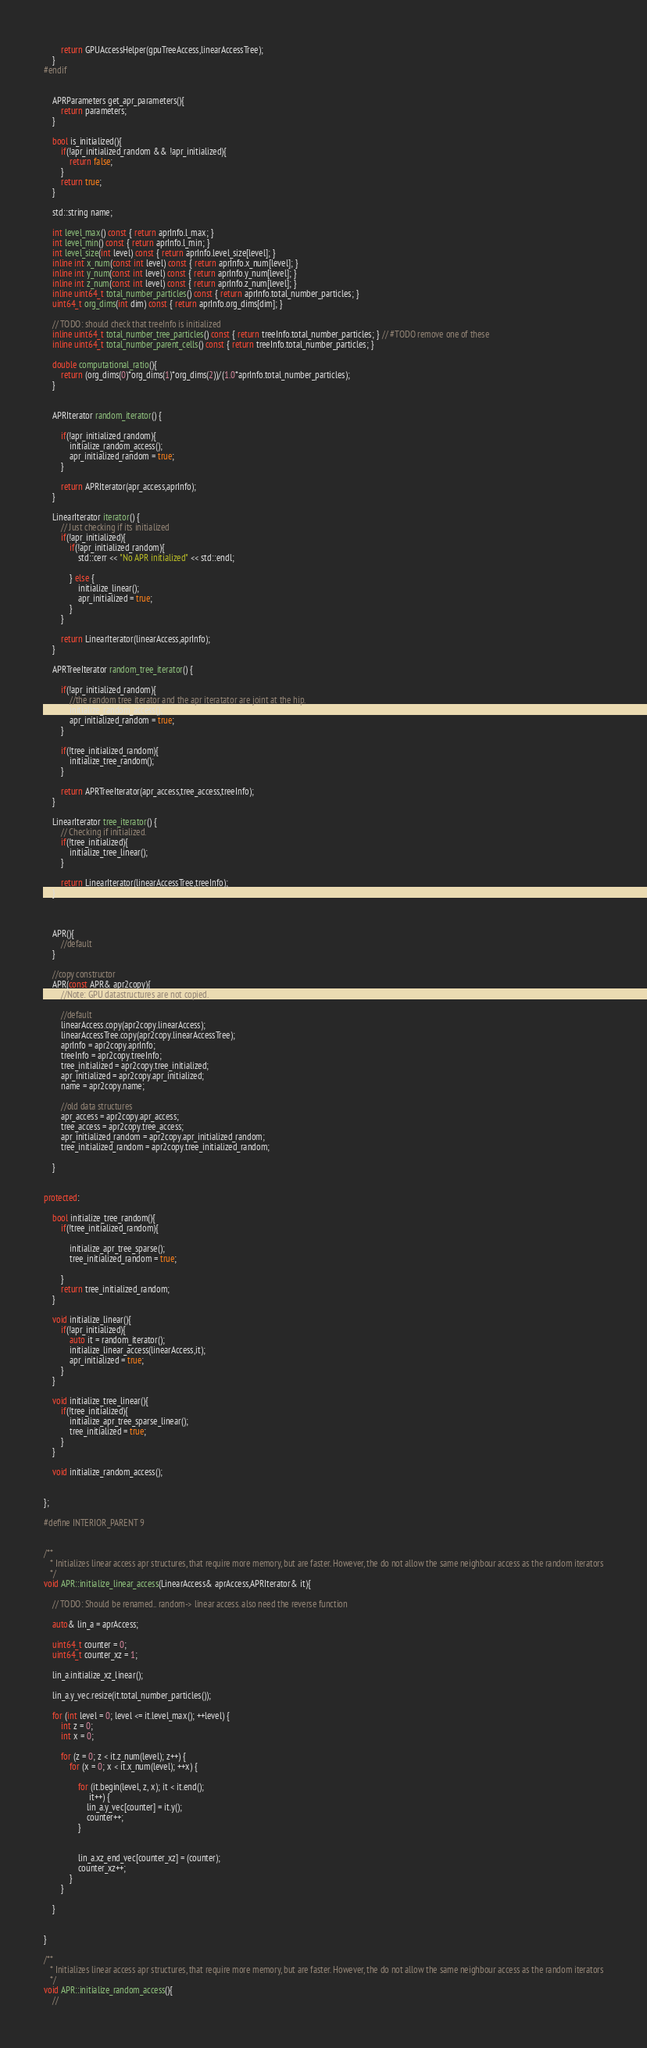Convert code to text. <code><loc_0><loc_0><loc_500><loc_500><_C++_>        return GPUAccessHelper(gpuTreeAccess,linearAccessTree);
    }
#endif


    APRParameters get_apr_parameters(){
        return parameters;
    }

    bool is_initialized(){
        if(!apr_initialized_random && !apr_initialized){
            return false;
        }
        return true;
    }

    std::string name;

    int level_max() const { return aprInfo.l_max; }
    int level_min() const { return aprInfo.l_min; }
    int level_size(int level) const { return aprInfo.level_size[level]; }
    inline int x_num(const int level) const { return aprInfo.x_num[level]; }
    inline int y_num(const int level) const { return aprInfo.y_num[level]; }
    inline int z_num(const int level) const { return aprInfo.z_num[level]; }
    inline uint64_t total_number_particles() const { return aprInfo.total_number_particles; }
    uint64_t org_dims(int dim) const { return aprInfo.org_dims[dim]; }

    // TODO: should check that treeInfo is initialized
    inline uint64_t total_number_tree_particles() const { return treeInfo.total_number_particles; } // #TODO remove one of these
    inline uint64_t total_number_parent_cells() const { return treeInfo.total_number_particles; }

    double computational_ratio(){
        return (org_dims(0)*org_dims(1)*org_dims(2))/(1.0*aprInfo.total_number_particles);
    }


    APRIterator random_iterator() {

        if(!apr_initialized_random){
            initialize_random_access();
            apr_initialized_random = true;
        }

        return APRIterator(apr_access,aprInfo);
    }

    LinearIterator iterator() {
        // Just checking if its initialized
        if(!apr_initialized){
            if(!apr_initialized_random){
                std::cerr << "No APR initialized" << std::endl;

            } else {
                initialize_linear();
                apr_initialized = true;
            }
        }

        return LinearIterator(linearAccess,aprInfo);
    }

    APRTreeIterator random_tree_iterator() {

        if(!apr_initialized_random){
            //the random tree iterator and the apr iteratator are joint at the hip.
            initialize_random_access();
            apr_initialized_random = true;
        }

        if(!tree_initialized_random){
            initialize_tree_random();
        }

        return APRTreeIterator(apr_access,tree_access,treeInfo);
    }

    LinearIterator tree_iterator() {
        // Checking if initialized.
        if(!tree_initialized){
            initialize_tree_linear();
        }

        return LinearIterator(linearAccessTree,treeInfo);
    }



    APR(){
        //default
    }

    //copy constructor
    APR(const APR& apr2copy){
        //Note: GPU datastructures are not copied.

        //default
        linearAccess.copy(apr2copy.linearAccess);
        linearAccessTree.copy(apr2copy.linearAccessTree);
        aprInfo = apr2copy.aprInfo;
        treeInfo = apr2copy.treeInfo;
        tree_initialized = apr2copy.tree_initialized;
        apr_initialized = apr2copy.apr_initialized;
        name = apr2copy.name;

        //old data structures
        apr_access = apr2copy.apr_access;
        tree_access = apr2copy.tree_access;
        apr_initialized_random = apr2copy.apr_initialized_random;
        tree_initialized_random = apr2copy.tree_initialized_random;

    }


protected:

    bool initialize_tree_random(){
        if(!tree_initialized_random){

            initialize_apr_tree_sparse();
            tree_initialized_random = true;

        }
        return tree_initialized_random;
    }

    void initialize_linear(){
        if(!apr_initialized){
            auto it = random_iterator();
            initialize_linear_access(linearAccess,it);
            apr_initialized = true;
        }
    }

    void initialize_tree_linear(){
        if(!tree_initialized){
            initialize_apr_tree_sparse_linear();
            tree_initialized = true;
        }
    }

    void initialize_random_access();


};

#define INTERIOR_PARENT 9


/**
   * Initializes linear access apr structures, that require more memory, but are faster. However, the do not allow the same neighbour access as the random iterators
   */
void APR::initialize_linear_access(LinearAccess& aprAccess,APRIterator& it){

    // TODO: Should be renamed.. random-> linear access. also need the reverse function

    auto& lin_a = aprAccess;

    uint64_t counter = 0;
    uint64_t counter_xz = 1;

    lin_a.initialize_xz_linear();

    lin_a.y_vec.resize(it.total_number_particles());

    for (int level = 0; level <= it.level_max(); ++level) {
        int z = 0;
        int x = 0;

        for (z = 0; z < it.z_num(level); z++) {
            for (x = 0; x < it.x_num(level); ++x) {

                for (it.begin(level, z, x); it < it.end();
                     it++) {
                    lin_a.y_vec[counter] = it.y();
                    counter++;
                }


                lin_a.xz_end_vec[counter_xz] = (counter);
                counter_xz++;
            }
        }

    }


}

/**
   * Initializes linear access apr structures, that require more memory, but are faster. However, the do not allow the same neighbour access as the random iterators
   */
void APR::initialize_random_access(){
    //</code> 